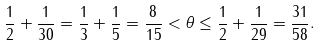Convert formula to latex. <formula><loc_0><loc_0><loc_500><loc_500>\frac { 1 } { 2 } + \frac { 1 } { 3 0 } = \frac { 1 } { 3 } + \frac { 1 } { 5 } = \frac { 8 } { 1 5 } < \theta \leq \frac { 1 } { 2 } + \frac { 1 } { 2 9 } = \frac { 3 1 } { 5 8 } .</formula> 